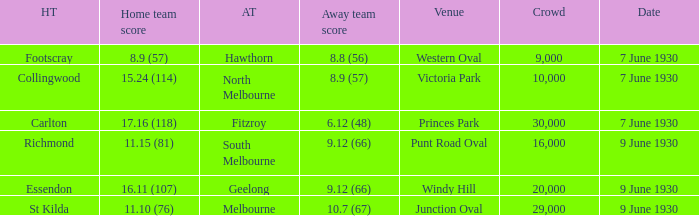What is the smallest crowd to see the away team score 10.7 (67)? 29000.0. 